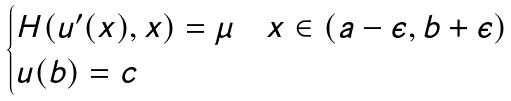<formula> <loc_0><loc_0><loc_500><loc_500>\begin{cases} H ( u ^ { \prime } ( x ) , x ) = \mu & x \in ( a - \epsilon , b + \epsilon ) \\ u ( b ) = c & \\ \end{cases}</formula> 